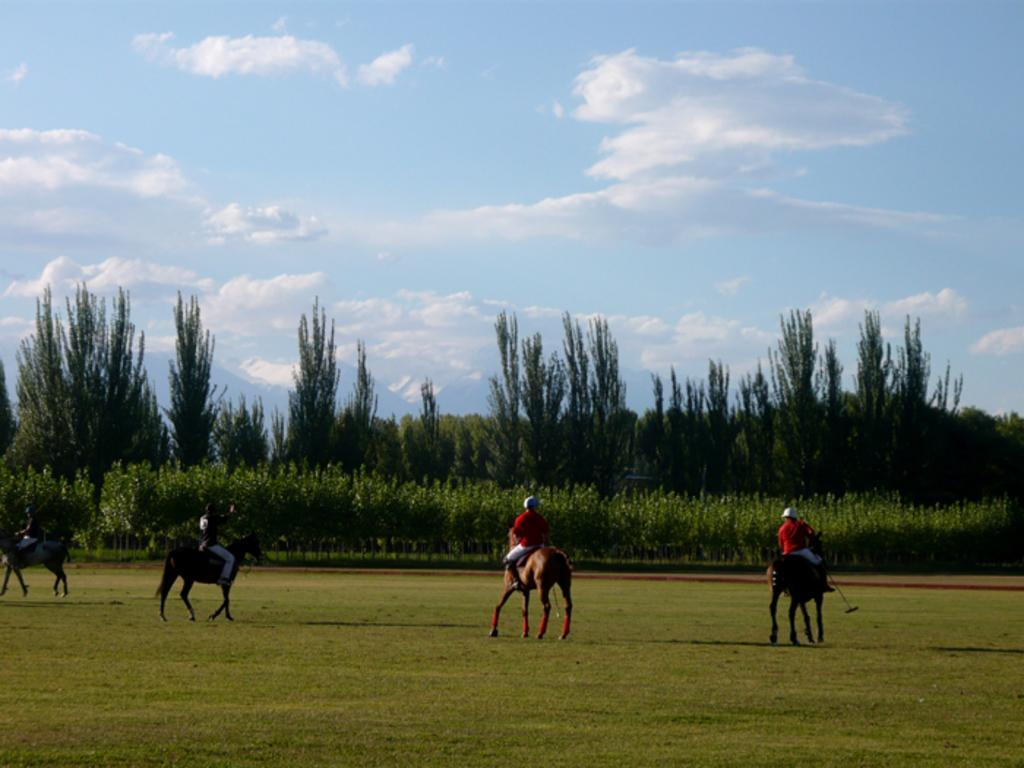What are the main subjects in the center of the image? There are persons sitting on horses in the center of the image. What can be seen in the background of the image? There are trees in the background of the image. How would you describe the sky in the image? The sky is cloudy in the image. What type of terrain is visible in the image? There is grass on the ground in the image. What type of receipt can be seen falling from the sky in the image? There is no receipt present in the image; it only features persons sitting on horses, trees in the background, a cloudy sky, and grass on the ground. 